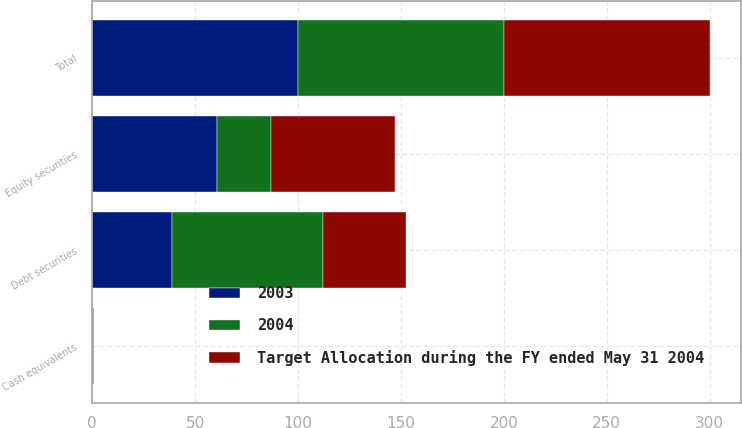Convert chart to OTSL. <chart><loc_0><loc_0><loc_500><loc_500><stacked_bar_chart><ecel><fcel>Equity securities<fcel>Debt securities<fcel>Cash equivalents<fcel>Total<nl><fcel>2003<fcel>60.7<fcel>39<fcel>0.3<fcel>100<nl><fcel>2004<fcel>26.3<fcel>73.3<fcel>0.4<fcel>100<nl><fcel>Target Allocation during the FY ended May 31 2004<fcel>60<fcel>40<fcel>0<fcel>100<nl></chart> 